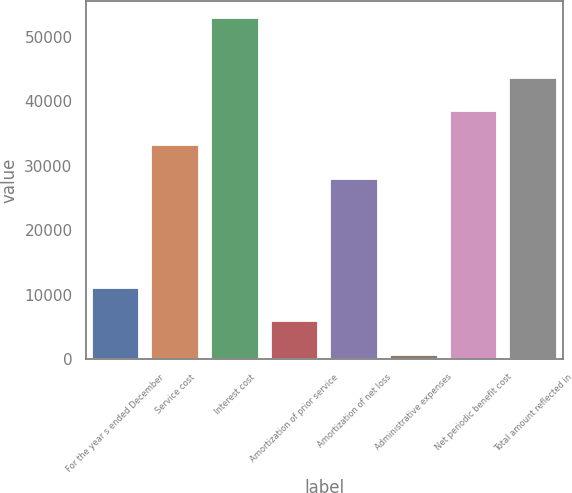Convert chart. <chart><loc_0><loc_0><loc_500><loc_500><bar_chart><fcel>For the year s ended December<fcel>Service cost<fcel>Interest cost<fcel>Amortization of prior service<fcel>Amortization of net loss<fcel>Administrative expenses<fcel>Net periodic benefit cost<fcel>Total amount reflected in<nl><fcel>11114.4<fcel>33234.7<fcel>52960<fcel>5883.7<fcel>28004<fcel>653<fcel>38465.4<fcel>43696.1<nl></chart> 